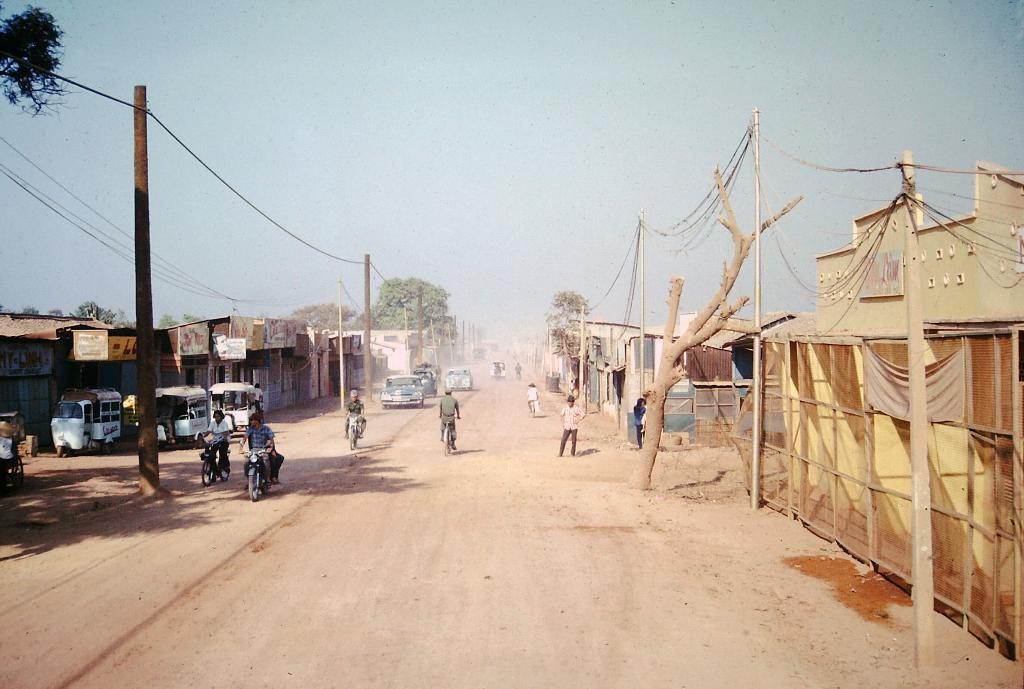What type of view is shown in the image? The image is an outside view. What structures can be seen in the image? There are houses in the image. What other objects are present in the image? There are poles, trees, and wires in the image. Are there any living beings visible in the image? Yes, there are people in the image. What are the people doing in the image? People are riding vehicles on the road. What can be seen at the top of the image? The sky is visible at the top of the image. What type of plastic toys can be seen scattered on the ground in the image? There is no mention of plastic toys in the image; the image features houses, poles, trees, wires, people, vehicles, and a visible sky. How many birds are perched on the wires in the image? There are no birds present in the image; it features houses, poles, trees, wires, people, vehicles, and a visible sky. 